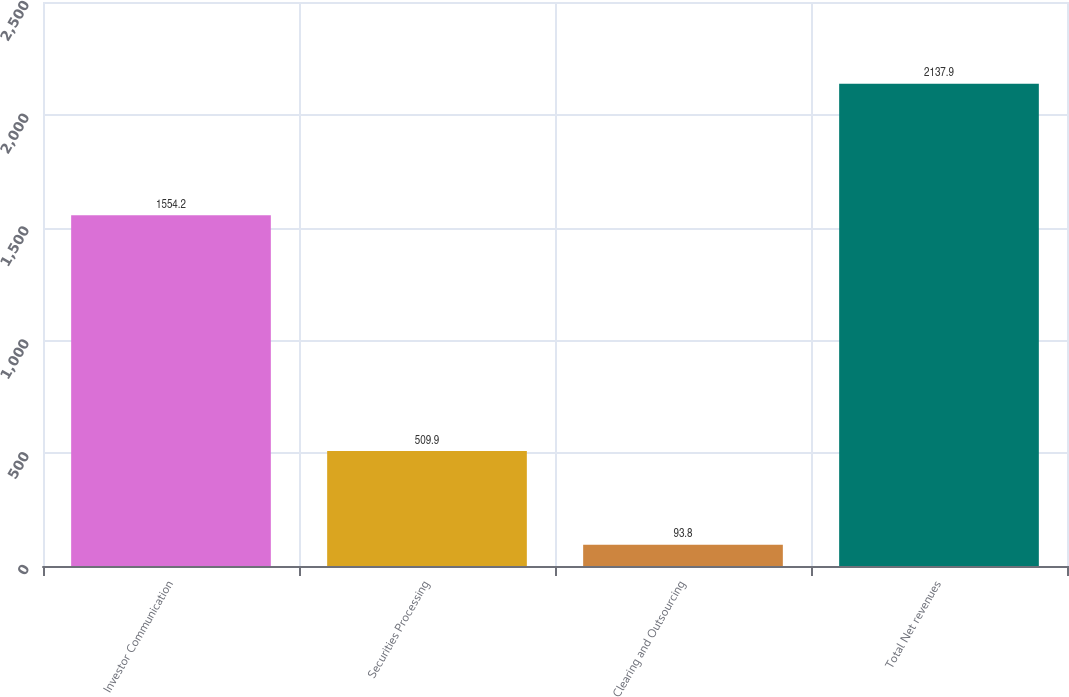<chart> <loc_0><loc_0><loc_500><loc_500><bar_chart><fcel>Investor Communication<fcel>Securities Processing<fcel>Clearing and Outsourcing<fcel>Total Net revenues<nl><fcel>1554.2<fcel>509.9<fcel>93.8<fcel>2137.9<nl></chart> 